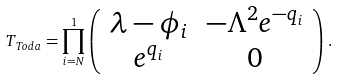Convert formula to latex. <formula><loc_0><loc_0><loc_500><loc_500>T _ { T o d a } = \prod _ { i = N } ^ { 1 } \left ( \begin{array} { c c } \lambda - \phi _ { i } & - \Lambda ^ { 2 } e ^ { - q _ { i } } \\ e ^ { q _ { i } } & 0 \end{array} \right ) .</formula> 